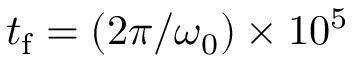Convert formula to latex. <formula><loc_0><loc_0><loc_500><loc_500>t _ { f } = ( 2 \pi / \omega _ { 0 } ) \times 1 0 ^ { 5 }</formula> 